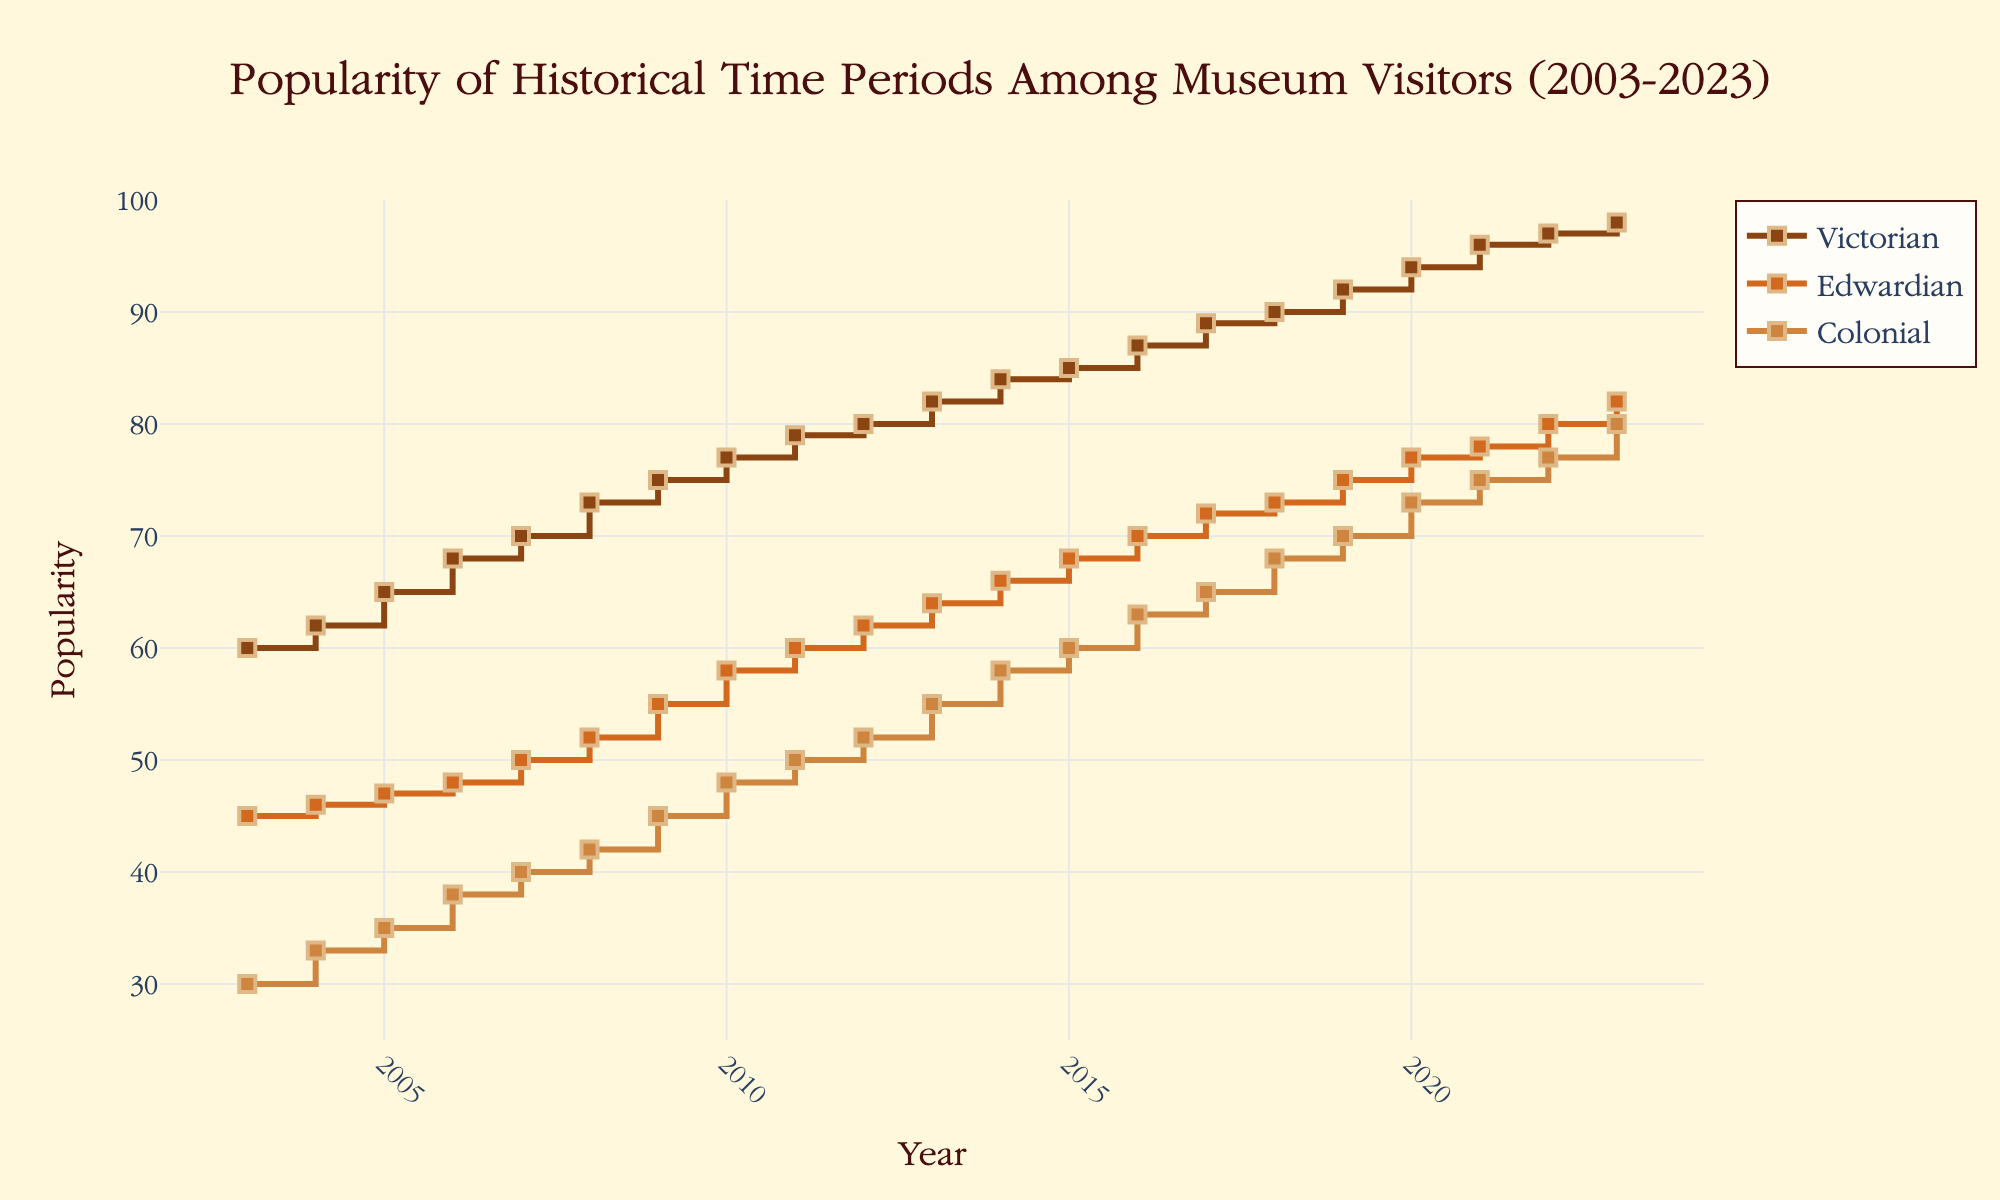What is the title of the plot? The title is displayed at the top center of the plot. It reads “Popularity of Historical Time Periods Among Museum Visitors (2003-2023).”
Answer: Popularity of Historical Time Periods Among Museum Visitors (2003-2023) What are the time periods compared in the plot? The plot compares three historical time periods: Victorian, Edwardian, and Colonial. These periods are denoted by different colored lines with corresponding labels in the legend.
Answer: Victorian, Edwardian, Colonial Which time period was most popular in 2010? By looking at the 2010 mark on the x-axis, we see that the Victorian line is the highest on the y-axis at that point, indicating that Victorian was the most popular time period in 2010.
Answer: Victorian How does the popularity of the Colonial period change from 2003 to 2023? The Colonial period starts at a popularity of 30 in 2003 and increases to 80 in 2023. By looking at the step increments each year, it consistently grows over the 20-year span.
Answer: Increases from 30 to 80 Which time period had the smallest popularity increase over the 20 years? To determine the smallest increase, check the beginning and ending popularity values for each period. Victorian increases from 60 to 98 (38 points), Edwardian from 45 to 82 (37 points), and Colonial from 30 to 80 (50 points). Edwardian shows the smallest increase of 37 points.
Answer: Edwardian What is the approximate average popularity of the Edwardian period over the 20 years? Sum the Edwardian values from each year and divide by the number of years (20). The sum is 1140 (each year's values as listed), so the average is 1140/20.
Answer: 57 In which years did the Victorian period have a popularity greater than 80? The Victorian period had a popularity greater than 80 in the years 2012 to 2023. This is observed by checking each year's values and matching with the points on the plot.
Answer: 2012-2023 How does the popularity trend of the Edwardian period compare to the Victorian period from 2003 to 2023? Both periods show an increasing trend. The Victorian period consistently has higher popularity than the Edwardian period throughout all years. By checking the plotted lines, the Victorian trend increases more sharply than the Edwardian, especially in the later years.
Answer: Victorian increases more sharply and stays higher What was the largest annual increase in popularity for the Colonial period, and in which year did it occur? Check the yearly steps of the Colonial plot. The largest increase is from 2020 to 2021, jumping from 73 to 75.
Answer: 2 points (2020-2021) Which historical period had the steepest climb in popularity between 2018 and 2019? Compare the line slopes from 2018 to 2019. The Victorian period rises from 90 to 92, the Edwardian period from 73 to 75, and the Colonial period from 68 to 70. The Victorian period shows the highest increase of 2 points.
Answer: Victorian 